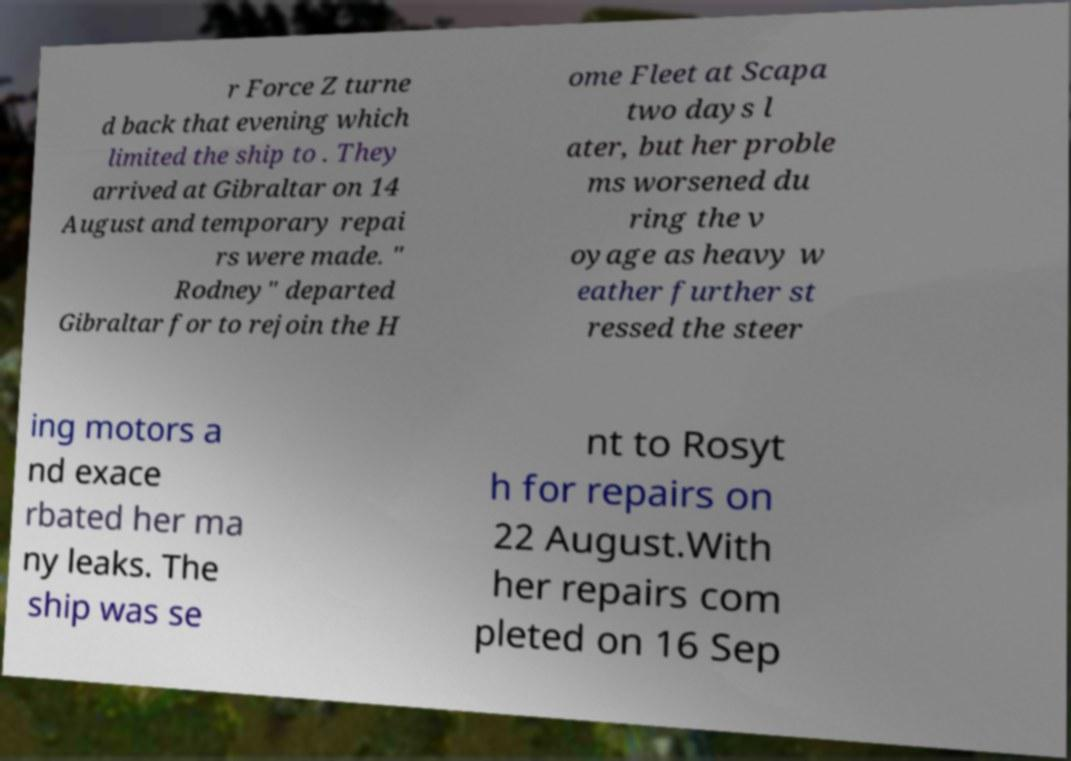What messages or text are displayed in this image? I need them in a readable, typed format. r Force Z turne d back that evening which limited the ship to . They arrived at Gibraltar on 14 August and temporary repai rs were made. " Rodney" departed Gibraltar for to rejoin the H ome Fleet at Scapa two days l ater, but her proble ms worsened du ring the v oyage as heavy w eather further st ressed the steer ing motors a nd exace rbated her ma ny leaks. The ship was se nt to Rosyt h for repairs on 22 August.With her repairs com pleted on 16 Sep 